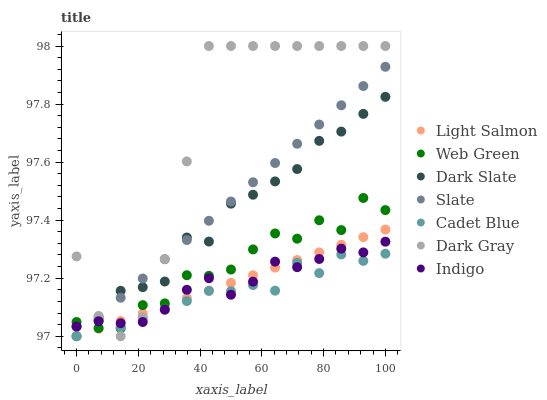Does Cadet Blue have the minimum area under the curve?
Answer yes or no. Yes. Does Dark Gray have the maximum area under the curve?
Answer yes or no. Yes. Does Indigo have the minimum area under the curve?
Answer yes or no. No. Does Indigo have the maximum area under the curve?
Answer yes or no. No. Is Slate the smoothest?
Answer yes or no. Yes. Is Dark Gray the roughest?
Answer yes or no. Yes. Is Cadet Blue the smoothest?
Answer yes or no. No. Is Cadet Blue the roughest?
Answer yes or no. No. Does Light Salmon have the lowest value?
Answer yes or no. Yes. Does Cadet Blue have the lowest value?
Answer yes or no. No. Does Dark Gray have the highest value?
Answer yes or no. Yes. Does Indigo have the highest value?
Answer yes or no. No. Is Light Salmon less than Dark Slate?
Answer yes or no. Yes. Is Dark Slate greater than Light Salmon?
Answer yes or no. Yes. Does Cadet Blue intersect Light Salmon?
Answer yes or no. Yes. Is Cadet Blue less than Light Salmon?
Answer yes or no. No. Is Cadet Blue greater than Light Salmon?
Answer yes or no. No. Does Light Salmon intersect Dark Slate?
Answer yes or no. No. 